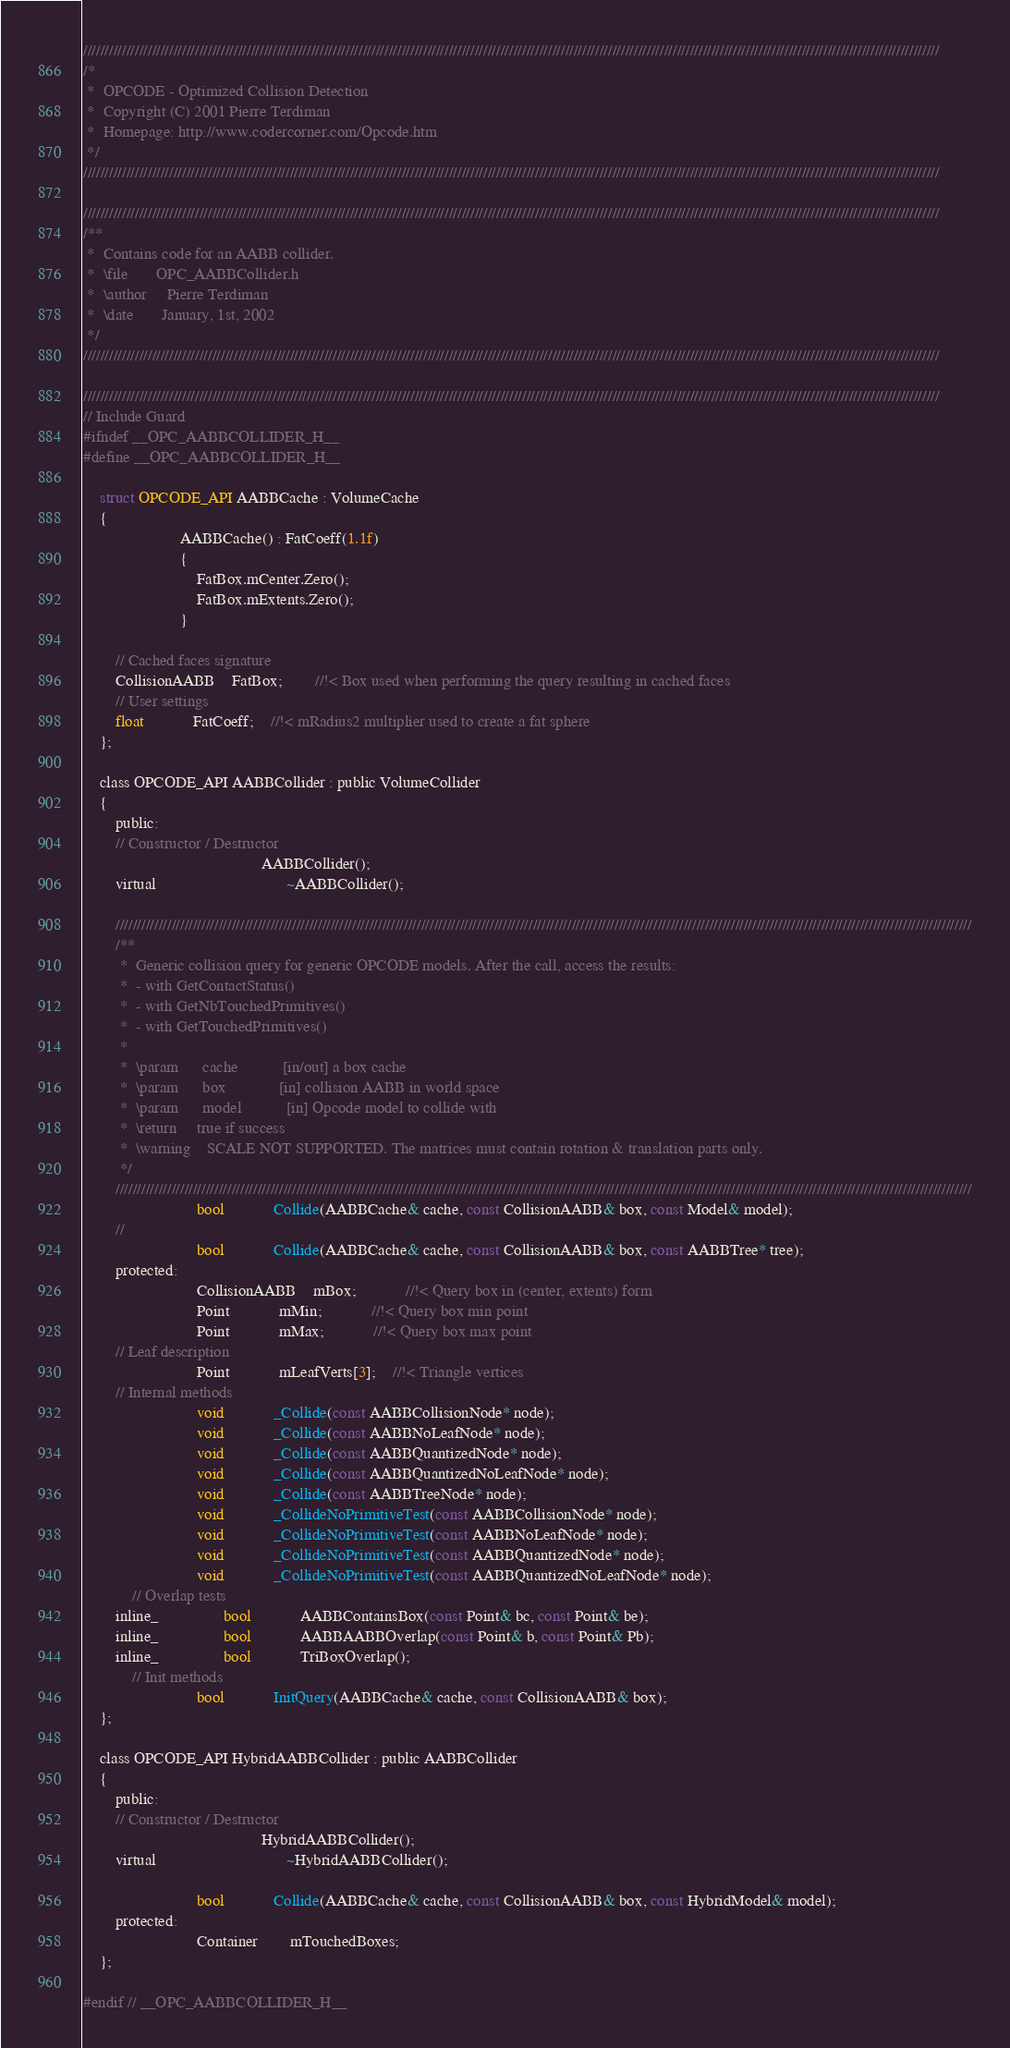Convert code to text. <code><loc_0><loc_0><loc_500><loc_500><_C_>///////////////////////////////////////////////////////////////////////////////////////////////////////////////////////////////////////////////////////////////////////////////////////////////////////
/*
 *	OPCODE - Optimized Collision Detection
 *	Copyright (C) 2001 Pierre Terdiman
 *	Homepage: http://www.codercorner.com/Opcode.htm
 */
///////////////////////////////////////////////////////////////////////////////////////////////////////////////////////////////////////////////////////////////////////////////////////////////////////

///////////////////////////////////////////////////////////////////////////////////////////////////////////////////////////////////////////////////////////////////////////////////////////////////////
/**
 *	Contains code for an AABB collider.
 *	\file		OPC_AABBCollider.h
 *	\author		Pierre Terdiman
 *	\date		January, 1st, 2002
 */
///////////////////////////////////////////////////////////////////////////////////////////////////////////////////////////////////////////////////////////////////////////////////////////////////////

///////////////////////////////////////////////////////////////////////////////////////////////////////////////////////////////////////////////////////////////////////////////////////////////////////
// Include Guard
#ifndef __OPC_AABBCOLLIDER_H__
#define __OPC_AABBCOLLIDER_H__

	struct OPCODE_API AABBCache : VolumeCache
	{
						AABBCache() : FatCoeff(1.1f)
						{
							FatBox.mCenter.Zero();
							FatBox.mExtents.Zero();
						}

		// Cached faces signature
		CollisionAABB	FatBox;		//!< Box used when performing the query resulting in cached faces
		// User settings
		float			FatCoeff;	//!< mRadius2 multiplier used to create a fat sphere
	};

	class OPCODE_API AABBCollider : public VolumeCollider
	{
		public:
		// Constructor / Destructor
											AABBCollider();
		virtual								~AABBCollider();

		///////////////////////////////////////////////////////////////////////////////////////////////////////////////////////////////////////////////////////////////////////////////////////////////////////
		/**
		 *	Generic collision query for generic OPCODE models. After the call, access the results:
		 *	- with GetContactStatus()
		 *	- with GetNbTouchedPrimitives()
		 *	- with GetTouchedPrimitives()
		 *
		 *	\param		cache			[in/out] a box cache
		 *	\param		box				[in] collision AABB in world space
		 *	\param		model			[in] Opcode model to collide with
		 *	\return		true if success
		 *	\warning	SCALE NOT SUPPORTED. The matrices must contain rotation & translation parts only.
		 */
		///////////////////////////////////////////////////////////////////////////////////////////////////////////////////////////////////////////////////////////////////////////////////////////////////////
							bool			Collide(AABBCache& cache, const CollisionAABB& box, const Model& model);
		//
							bool			Collide(AABBCache& cache, const CollisionAABB& box, const AABBTree* tree);
		protected:
							CollisionAABB	mBox;			//!< Query box in (center, extents) form
							Point			mMin;			//!< Query box min point
							Point			mMax;			//!< Query box max point
		// Leaf description
							Point			mLeafVerts[3];	//!< Triangle vertices
		// Internal methods
							void			_Collide(const AABBCollisionNode* node);
							void			_Collide(const AABBNoLeafNode* node);
							void			_Collide(const AABBQuantizedNode* node);
							void			_Collide(const AABBQuantizedNoLeafNode* node);
							void			_Collide(const AABBTreeNode* node);
							void			_CollideNoPrimitiveTest(const AABBCollisionNode* node);
							void			_CollideNoPrimitiveTest(const AABBNoLeafNode* node);
							void			_CollideNoPrimitiveTest(const AABBQuantizedNode* node);
							void			_CollideNoPrimitiveTest(const AABBQuantizedNoLeafNode* node);
			// Overlap tests
		inline_				bool			AABBContainsBox(const Point& bc, const Point& be);
		inline_				bool			AABBAABBOverlap(const Point& b, const Point& Pb);
		inline_				bool			TriBoxOverlap();
			// Init methods
							bool			InitQuery(AABBCache& cache, const CollisionAABB& box);
	};

	class OPCODE_API HybridAABBCollider : public AABBCollider
	{
		public:
		// Constructor / Destructor
											HybridAABBCollider();
		virtual								~HybridAABBCollider();

							bool			Collide(AABBCache& cache, const CollisionAABB& box, const HybridModel& model);
		protected:
							Container		mTouchedBoxes;
	};

#endif // __OPC_AABBCOLLIDER_H__
</code> 